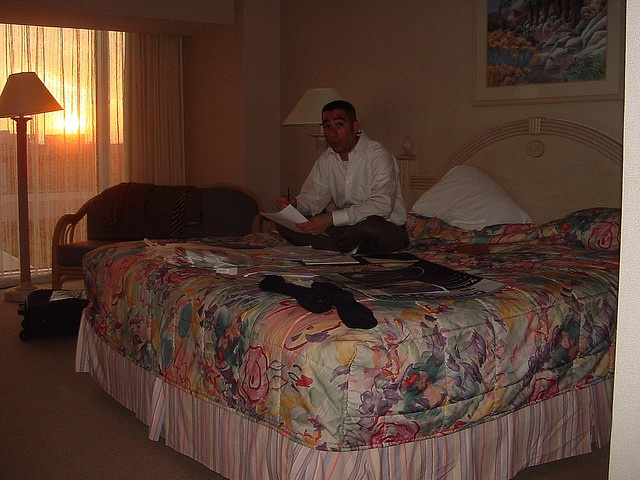Describe the objects in this image and their specific colors. I can see bed in maroon, black, and gray tones, couch in maroon, black, and brown tones, people in maroon, gray, and black tones, and suitcase in maroon, black, and gray tones in this image. 